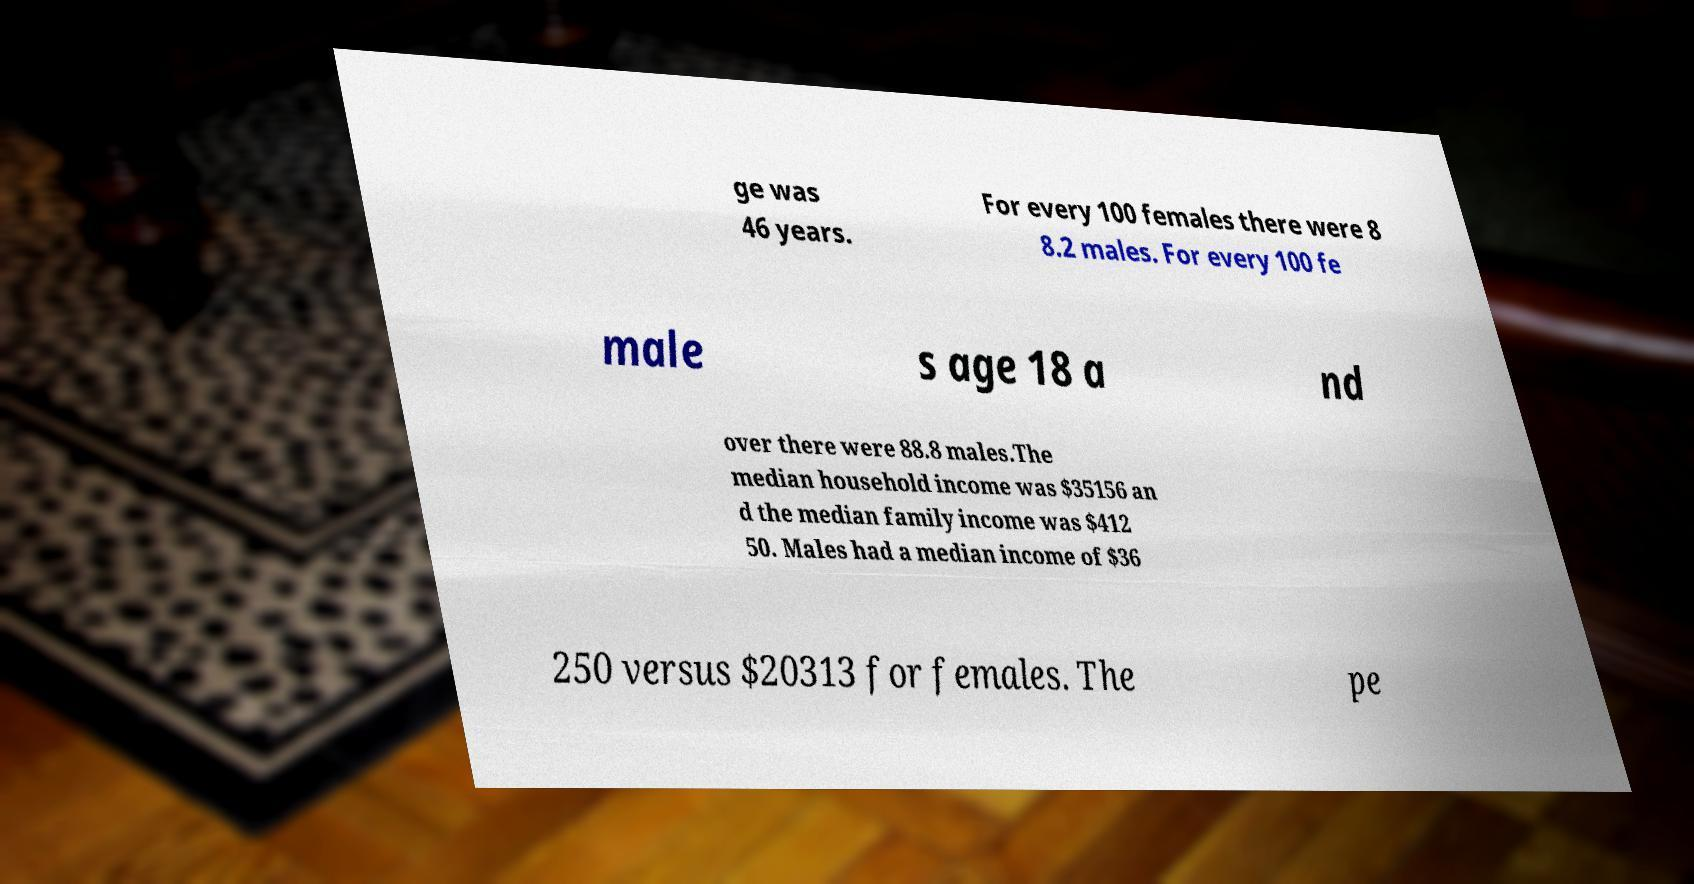Could you assist in decoding the text presented in this image and type it out clearly? ge was 46 years. For every 100 females there were 8 8.2 males. For every 100 fe male s age 18 a nd over there were 88.8 males.The median household income was $35156 an d the median family income was $412 50. Males had a median income of $36 250 versus $20313 for females. The pe 